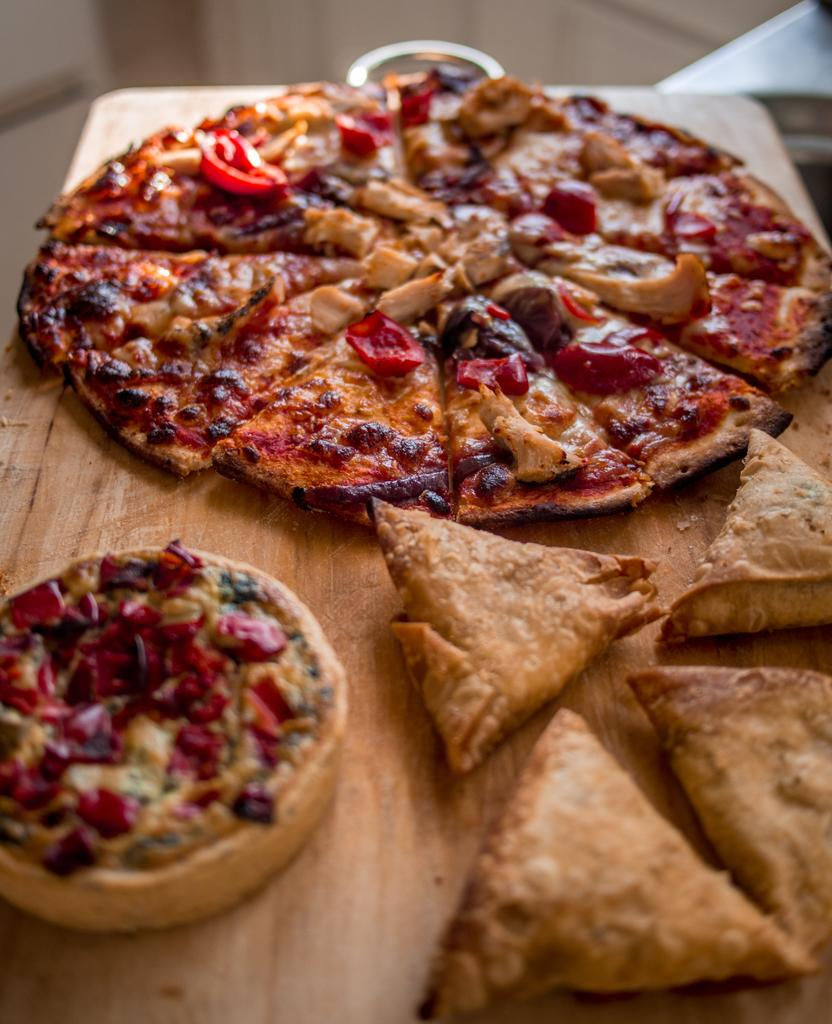What type of food is the main subject of the image? There is a pizza in the image. Can you describe any other food items visible in the image? There is other food on the table in the image. What type of breakfast is being served in the image? There is no mention of breakfast in the image, as it only features a pizza and other food items on the table. 